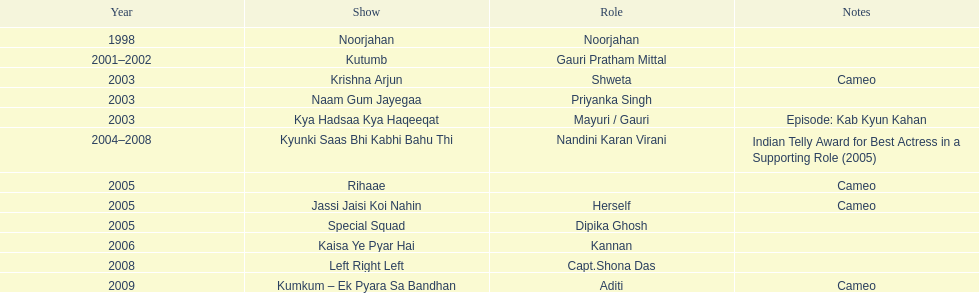The shows with at most 1 cameo Krishna Arjun, Rihaae, Jassi Jaisi Koi Nahin, Kumkum - Ek Pyara Sa Bandhan. 